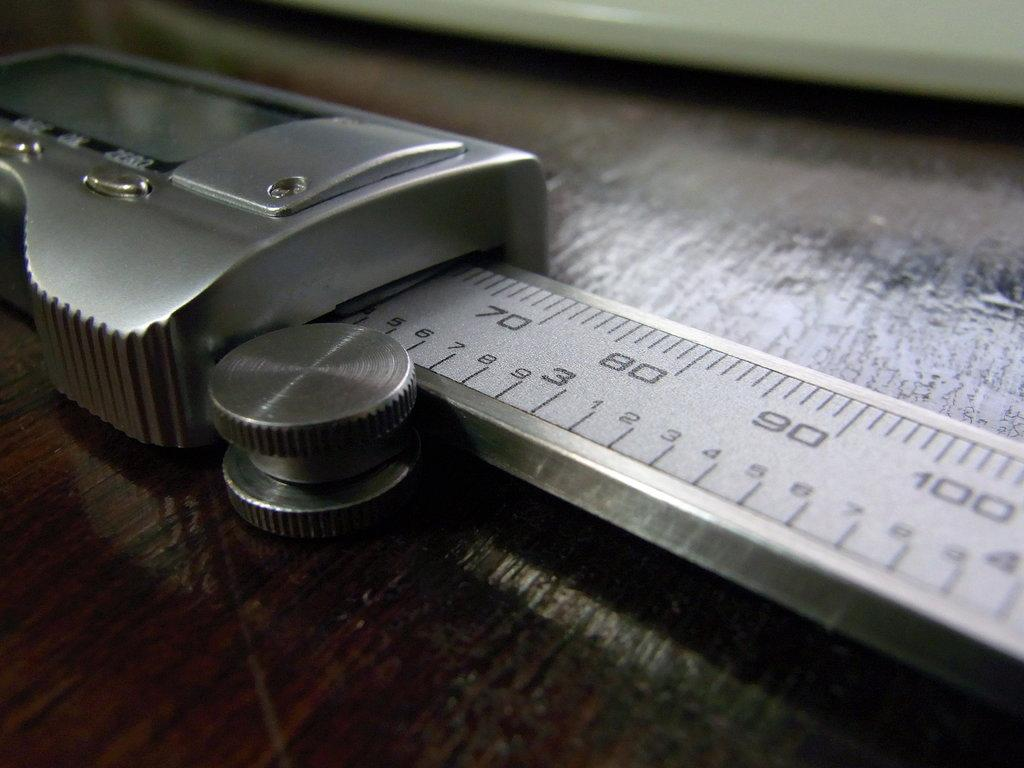<image>
Provide a brief description of the given image. A metal ruler with numbers ranging from 70 to 100 